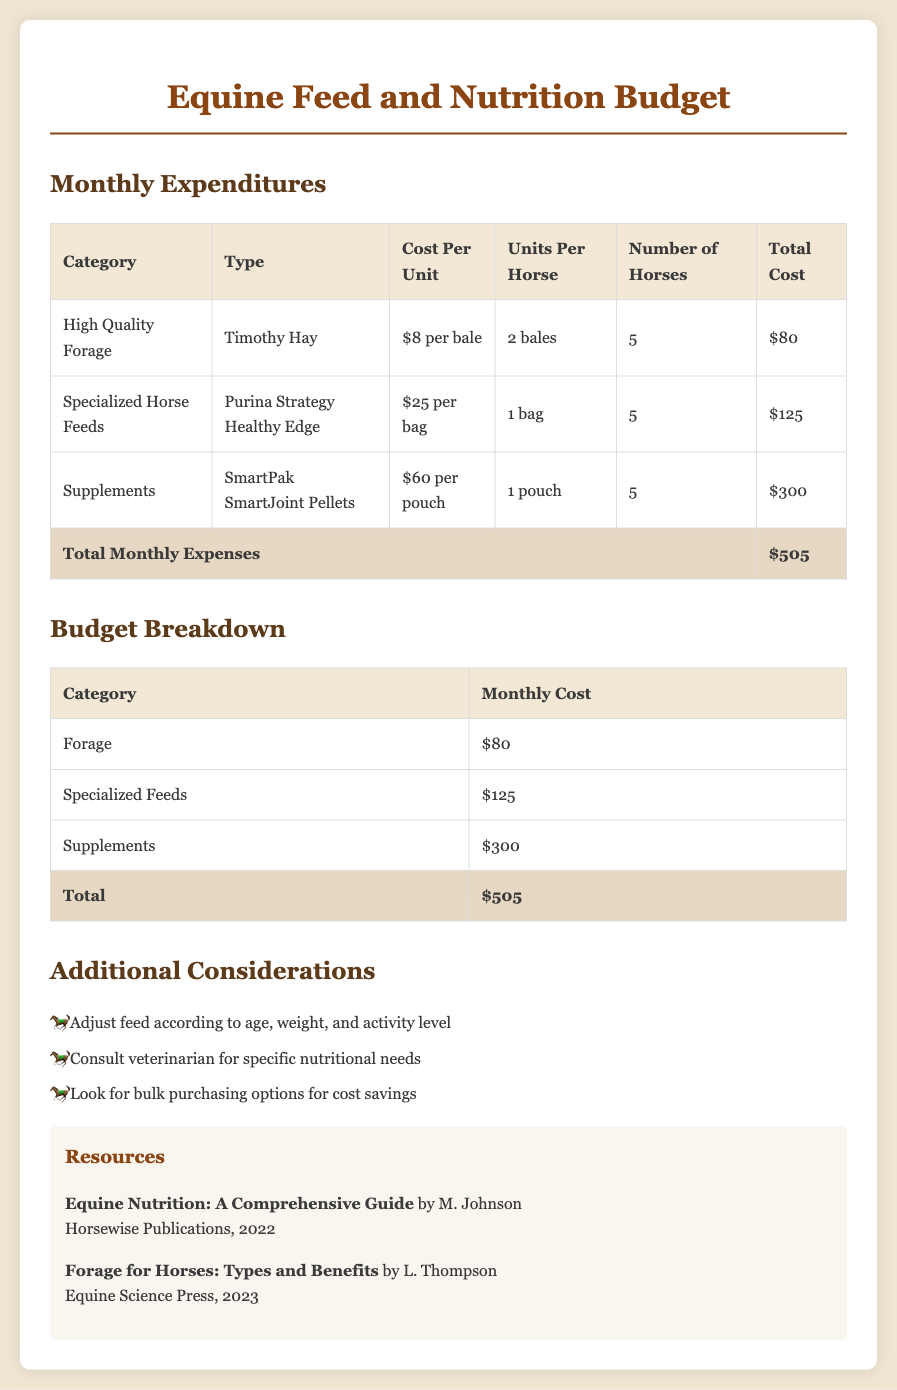What is the cost per bale of Timothy Hay? The cost per bale of Timothy Hay is specified in the table under Monthly Expenditures.
Answer: $8 per bale How many bags of Purina Strategy Healthy Edge are purchased per month? The table in the Monthly Expenditures section shows that 1 bag is purchased per horse.
Answer: 1 bag What is the total monthly expense for feed and supplements? The total monthly expenses are summed from the expenses listed in the Monthly Expenditures table.
Answer: $505 How much is allocated for supplements each month? The Monthly Expenditures table lists the total cost for supplements, allowing us to identify the allocation.
Answer: $300 What is the total cost of high-quality forage for five horses? The monthly cost for forage in the budget specifically indicates this amount for five horses.
Answer: $80 What does the document recommend for adjusting feed? The Additional Considerations section suggests ways to tailor feeding based on specific factors.
Answer: Age, weight, and activity level Who is the author of "Equine Nutrition: A Comprehensive Guide"? The resources section lists authors for each publication, including their names.
Answer: M. Johnson What month does this budget cover? The document doesn’t explicitly state the month but refers to it as a Monthly Expenditure budget, indicating it's meant for a specific month.
Answer: Monthly How many horses are being fed according to this budget? The number of horses is specified in the Monthly Expenditures table under the heading 'Number of Horses'.
Answer: 5 